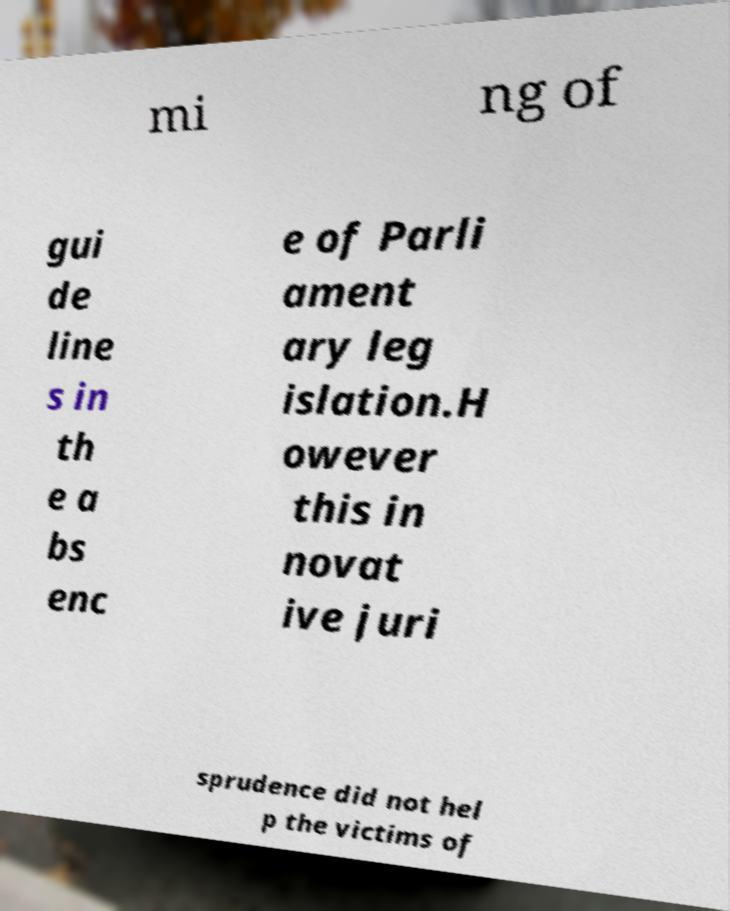Please read and relay the text visible in this image. What does it say? mi ng of gui de line s in th e a bs enc e of Parli ament ary leg islation.H owever this in novat ive juri sprudence did not hel p the victims of 